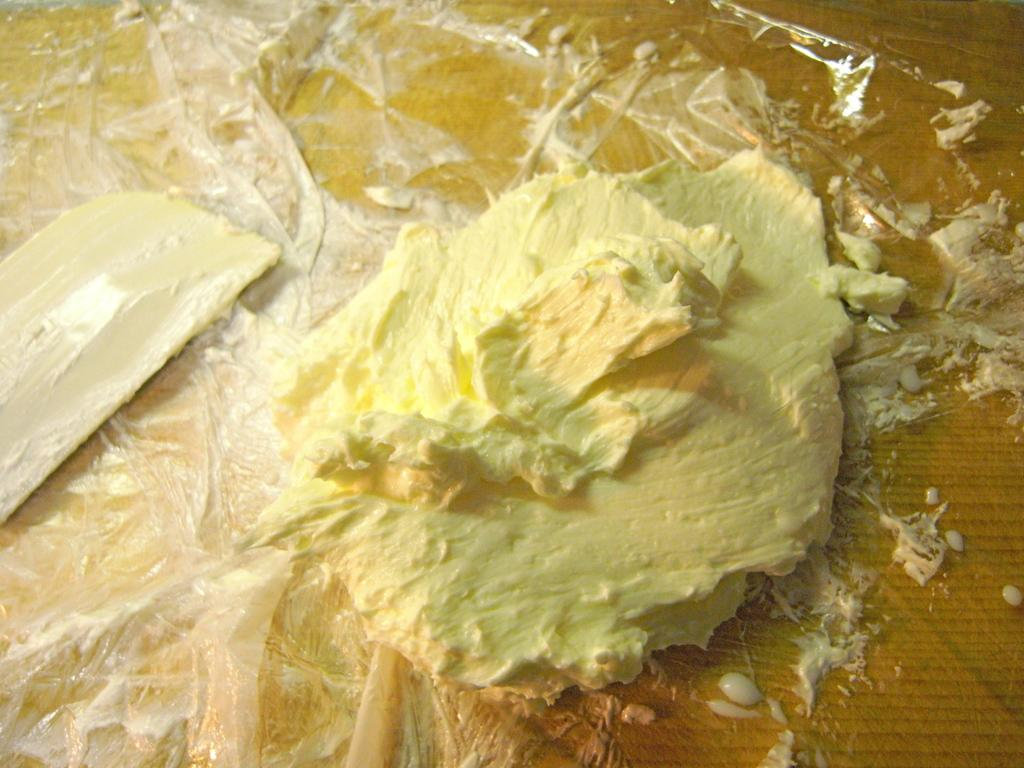What type of food item is present in the image? There is butter in the image. Can you describe the color of the butter? The butter has a yellow and cream color. What is the butter placed on in the image? The butter is on a plastic cover. What is the color or material of the surface beneath the plastic cover? The plastic cover is on a brown surface. Can you see any fish swimming in the alley in the image? There is no alley or fish present in the image; it features butter on a plastic cover on a brown surface. 